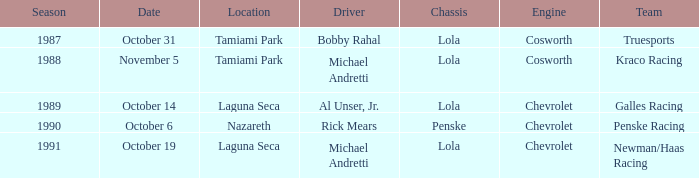When was the race at nazareth held? October 6. 